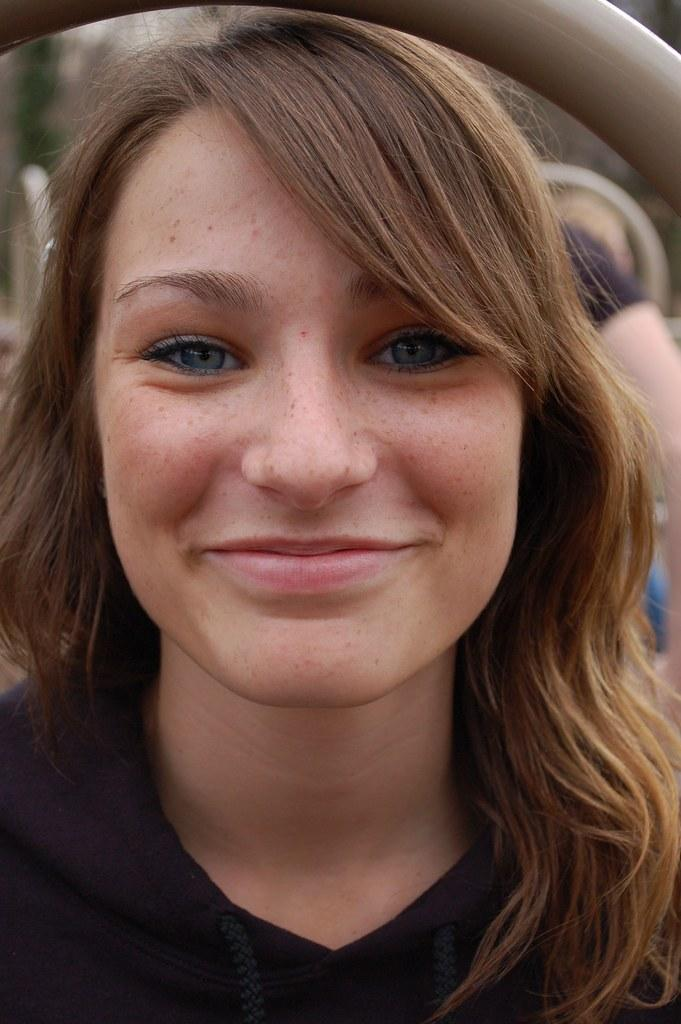Who is the main subject in the foreground of the image? There is a woman in the foreground of the image. What is the woman doing in the image? The woman is smiling. What is the woman wearing in the image? The woman is wearing a black dress. Can you see any loaves of bread floating down the river in the image? There is no river or loaves of bread present in the image. 